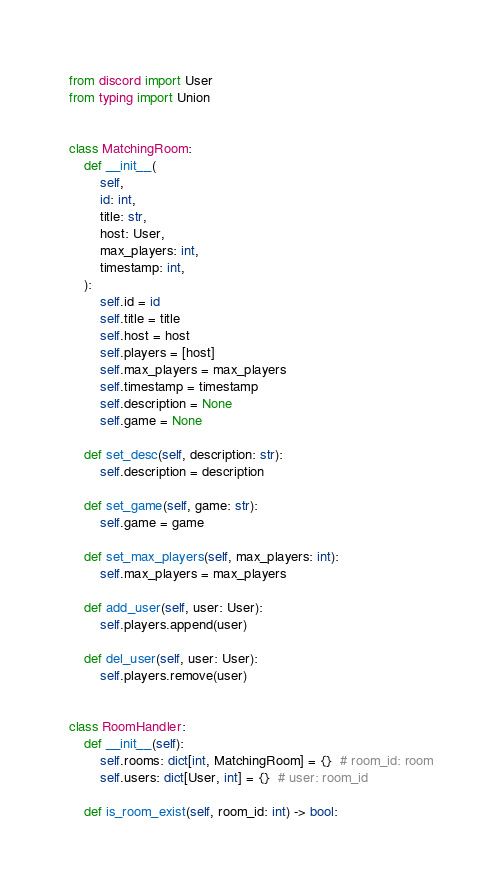Convert code to text. <code><loc_0><loc_0><loc_500><loc_500><_Python_>from discord import User
from typing import Union


class MatchingRoom:
    def __init__(
        self,
        id: int,
        title: str,
        host: User,
        max_players: int,
        timestamp: int,
    ):
        self.id = id
        self.title = title
        self.host = host
        self.players = [host]
        self.max_players = max_players
        self.timestamp = timestamp
        self.description = None
        self.game = None

    def set_desc(self, description: str):
        self.description = description

    def set_game(self, game: str):
        self.game = game
    
    def set_max_players(self, max_players: int):
        self.max_players = max_players

    def add_user(self, user: User):
        self.players.append(user)

    def del_user(self, user: User):
        self.players.remove(user)


class RoomHandler:
    def __init__(self):
        self.rooms: dict[int, MatchingRoom] = {}  # room_id: room
        self.users: dict[User, int] = {}  # user: room_id

    def is_room_exist(self, room_id: int) -> bool:</code> 